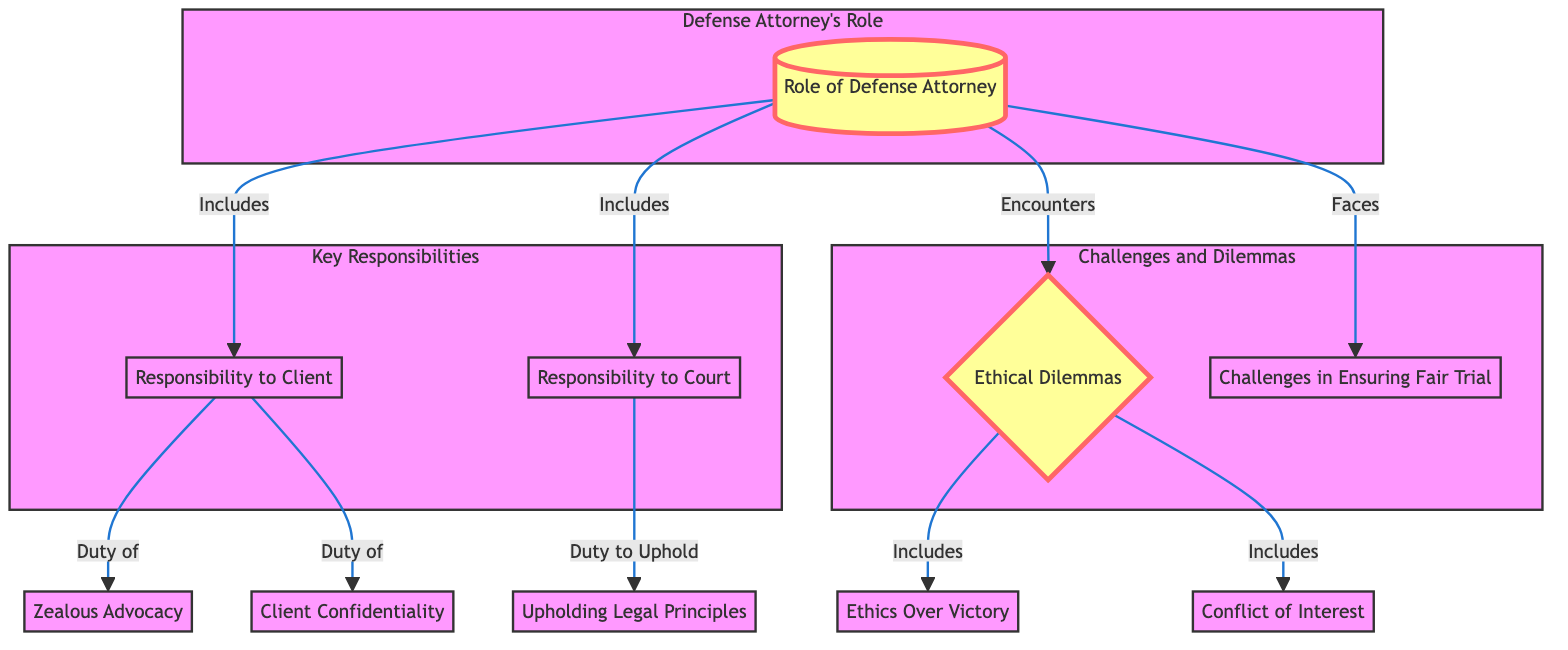What are the two main responsibilities of a defense attorney in the diagram? The diagram lists "Responsibility to Client" and "Responsibility to Court" as the two key responsibilities of a defense attorney.
Answer: Responsibility to Client, Responsibility to Court How many ethical dilemmas does the diagram highlight? The diagram shows three specific ethical dilemmas: "Ethics Over Victory," "Conflict of Interest," and "Client Confidentiality." Therefore, there are three ethical dilemmas highlighted.
Answer: Three What does the defense attorney's responsibility to the court involve? The diagram indicates that the responsibility to the court involves "Upholding Legal Principles."
Answer: Upholding Legal Principles Which duty relates directly to a defense attorney's responsibility to their client? According to the diagram, the duty that relates to a defense attorney's responsibility to their client is "Zealous Advocacy."
Answer: Zealous Advocacy What challenge does a defense attorney face in ensuring a fair trial? The diagram directly lists "Challenges in Ensuring Fair Trial" as a challenge that defense attorneys face when representing their clients.
Answer: Challenges in Ensuring Fair Trial Which node in the diagram connects "Ethical Dilemmas" to "Ethics Over Victory"? The diagram shows that "Ethical Dilemmas" directly includes the node "Ethics Over Victory," indicating a relationship between these two concepts.
Answer: Ethics Over Victory What type of advocacy is emphasized as part of a defense attorney's duty to their client? The diagram specifies "Zealous Advocacy" as the type of advocacy emphasized within the defense attorney's duties to their client.
Answer: Zealous Advocacy How does the diagram describe the relationship between the role of a defense attorney and ethical dilemmas? The diagram indicates that ethical dilemmas are encountered by the defense attorney, signifying that these dilemmas are a part of their role.
Answer: Encountered What is the primary focus of discussion in the "Challenges and Dilemmas" section of the diagram? The "Challenges and Dilemmas" section primarily discusses issues around "Challenges in Ensuring Fair Trial" and "Ethical Dilemmas."
Answer: Challenges in Ensuring Fair Trial, Ethical Dilemmas 